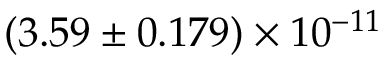<formula> <loc_0><loc_0><loc_500><loc_500>( 3 . 5 9 \pm 0 . 1 7 9 ) \times 1 0 ^ { - 1 1 }</formula> 